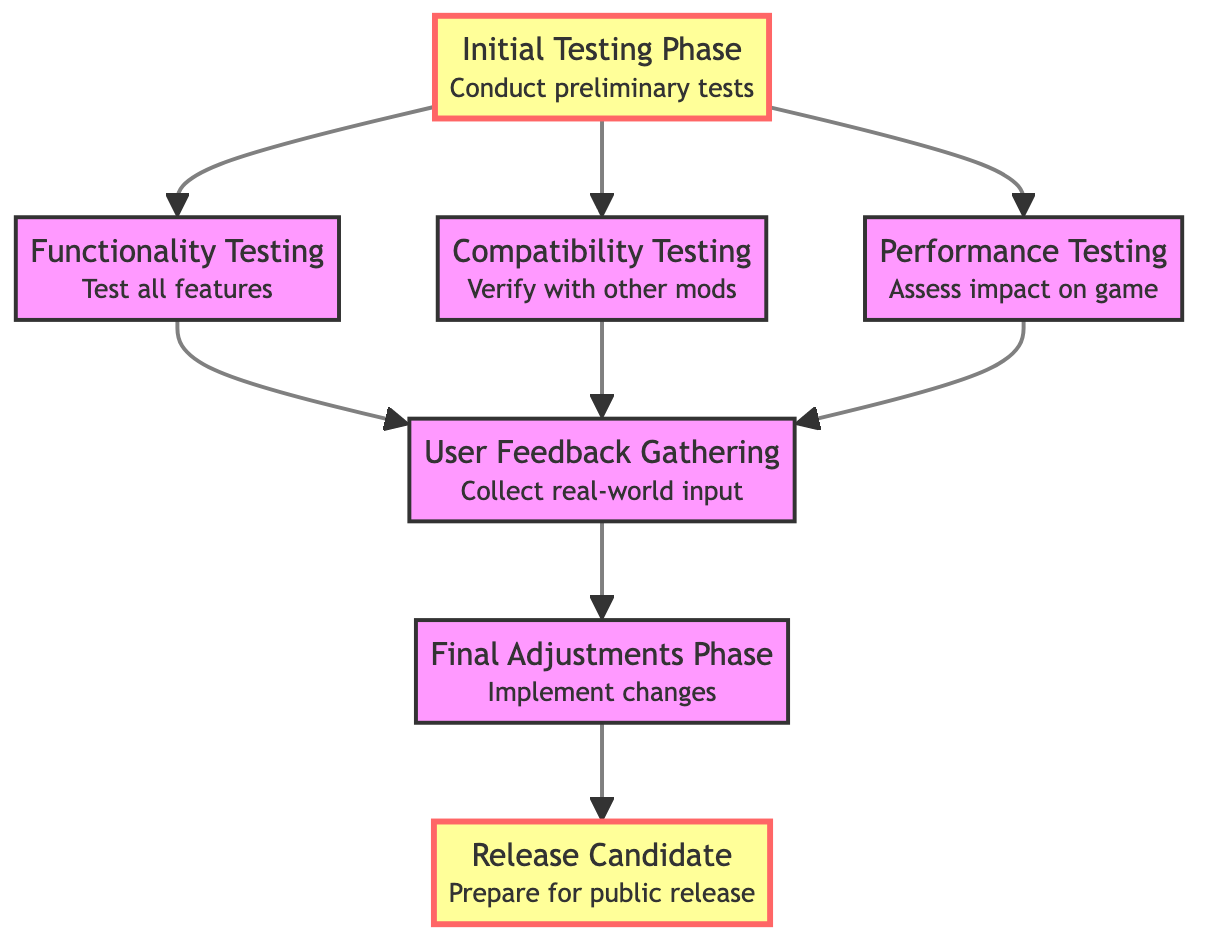What is the final phase before public release? The final phase before public release is designated as "Release Candidate." This is confirmed by observing that after the "Final Adjustments Phase," the flow leads directly to "Release Candidate" as the last step in the progression of testing phases.
Answer: Release Candidate How many testing phases are there in total? By counting the nodes listed in the diagram, there are seven distinct phases detailed, from "Initial Testing Phase" through to "Release Candidate." Each node represents a step in the testing process.
Answer: Seven Which testing phase comes after “User Feedback Gathering”? Following "User Feedback Gathering," the next phase in the flow is "Final Adjustments Phase." This can be seen as there is a direct connection leading from "User Feedback Gathering" to "Final Adjustments Phase," indicating that it follows logically in the process.
Answer: Final Adjustments Phase What is tested for in the “Performance Testing” phase? The "Performance Testing" phase specifically assesses the impact of the mod on game performance and frame rates. This is stated in the description that accompanies the "Performance Testing" node in the diagram.
Answer: Impact on game performance and frame rates Which phases share connections to “User Feedback Gathering”? The phases that connect to "User Feedback Gathering" are "Functionality Testing," "Compatibility Testing," and "Performance Testing." All three phases have direct edges that lead into "User Feedback Gathering," indicating they all contribute input for this phase.
Answer: Functionality Testing, Compatibility Testing, Performance Testing 